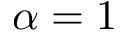<formula> <loc_0><loc_0><loc_500><loc_500>\alpha = 1</formula> 